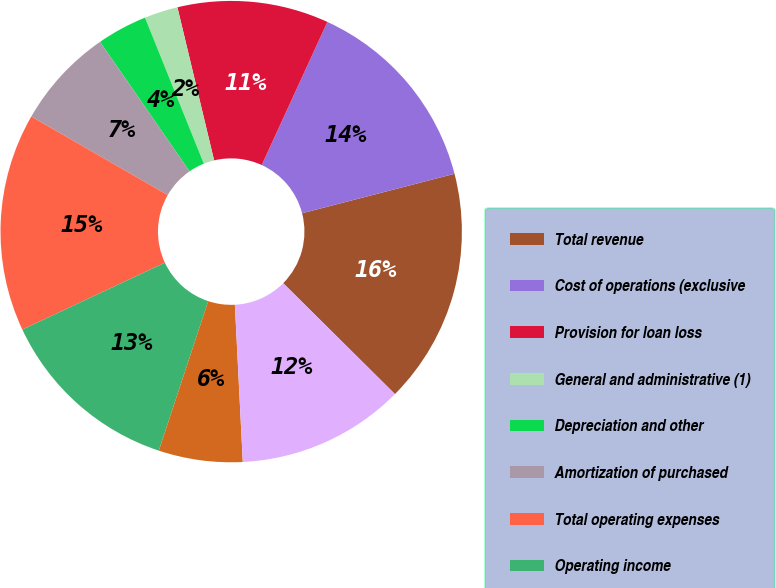Convert chart. <chart><loc_0><loc_0><loc_500><loc_500><pie_chart><fcel>Total revenue<fcel>Cost of operations (exclusive<fcel>Provision for loan loss<fcel>General and administrative (1)<fcel>Depreciation and other<fcel>Amortization of purchased<fcel>Total operating expenses<fcel>Operating income<fcel>Interest expense net<fcel>Income before income taxes<nl><fcel>16.47%<fcel>14.12%<fcel>10.59%<fcel>2.35%<fcel>3.53%<fcel>7.06%<fcel>15.29%<fcel>12.94%<fcel>5.88%<fcel>11.76%<nl></chart> 